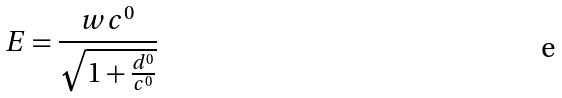Convert formula to latex. <formula><loc_0><loc_0><loc_500><loc_500>E = \frac { w c ^ { 0 } } { \sqrt { 1 + \frac { d ^ { 0 } } { c ^ { 0 } } } }</formula> 